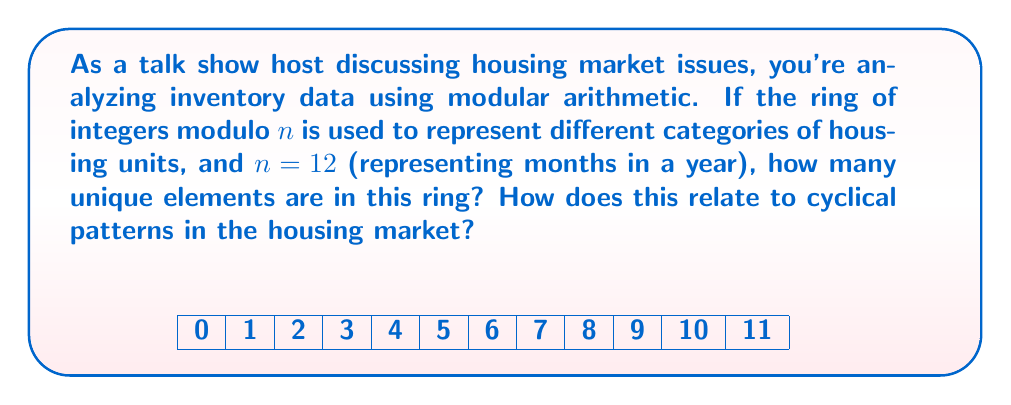Help me with this question. Let's approach this step-by-step:

1) The ring of integers modulo n, denoted as $\mathbb{Z}/n\mathbb{Z}$ or $\mathbb{Z}_n$, consists of the set of equivalence classes of integers modulo n.

2) For $n = 12$, we have:
   $$\mathbb{Z}_{12} = \{[0], [1], [2], [3], [4], [5], [6], [7], [8], [9], [10], [11]\}$$

3) Each element $[k]$ in this ring represents the set of all integers that leave the same remainder when divided by 12:
   $$[k] = \{..., k-24, k-12, k, k+12, k+24, ...\}$$

4) The number of elements in $\mathbb{Z}_n$ is always equal to n. In this case, there are 12 elements.

5) In the context of housing market analysis:
   - Each element can represent a month of the year.
   - The cyclic nature of $\mathbb{Z}_{12}$ mirrors the annual cycle in the housing market.
   - Operations in this ring (addition, subtraction) correspond to moving forward or backward in time while maintaining the cyclical pattern.

6) For example, if $[3]$ represents March:
   - $[3] + [4] = [7]$ (March + 4 months = July)
   - $[3] + [10] = [1]$ (March + 10 months = January of the next year)

This structure allows for easy modeling of recurring patterns and seasonality in housing inventory and market trends.
Answer: 12 elements; models annual market cycles 